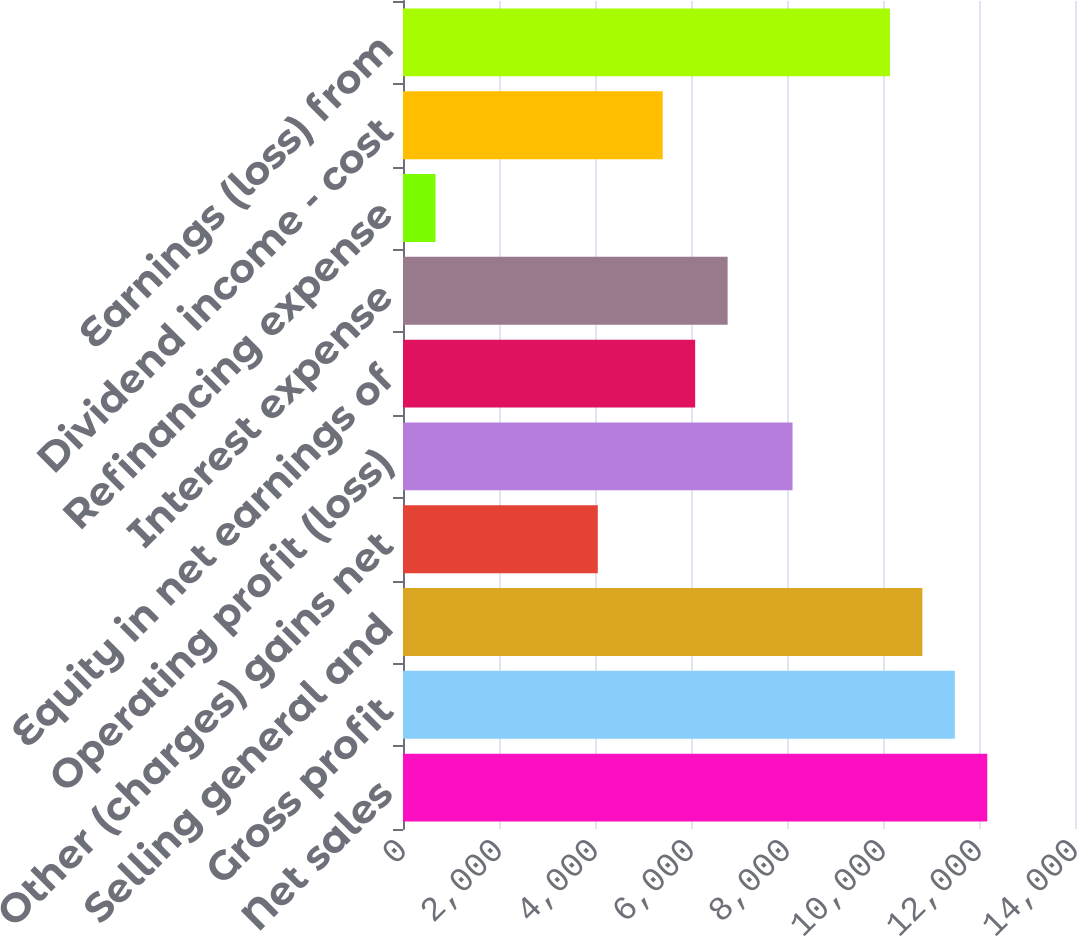Convert chart to OTSL. <chart><loc_0><loc_0><loc_500><loc_500><bar_chart><fcel>Net sales<fcel>Gross profit<fcel>Selling general and<fcel>Other (charges) gains net<fcel>Operating profit (loss)<fcel>Equity in net earnings of<fcel>Interest expense<fcel>Refinancing expense<fcel>Dividend income - cost<fcel>Earnings (loss) from<nl><fcel>12172.6<fcel>11496.4<fcel>10820.2<fcel>4058.2<fcel>8115.4<fcel>6086.8<fcel>6763<fcel>677.2<fcel>5410.6<fcel>10144<nl></chart> 